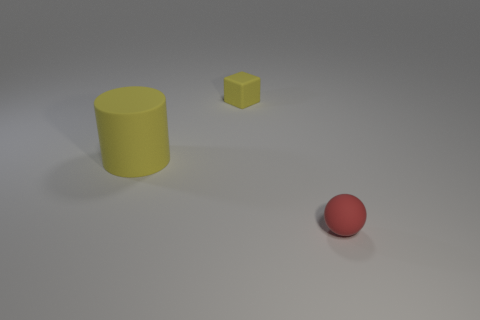How big is the rubber ball?
Provide a short and direct response. Small. Are there any tiny matte things on the left side of the yellow rubber thing that is on the left side of the yellow rubber object that is to the right of the big yellow cylinder?
Offer a very short reply. No. How many big things are either green blocks or yellow rubber blocks?
Provide a short and direct response. 0. Is there anything else that is the same color as the rubber block?
Give a very brief answer. Yes. There is a yellow object behind the yellow matte cylinder; does it have the same size as the small rubber ball?
Your answer should be very brief. Yes. What color is the tiny object that is in front of the object left of the yellow rubber thing that is behind the big matte cylinder?
Your answer should be compact. Red. What color is the small cube?
Offer a terse response. Yellow. Is the color of the cylinder the same as the cube?
Make the answer very short. Yes. There is a tiny object in front of the tiny object behind the tiny rubber ball; what color is it?
Provide a short and direct response. Red. What size is the cylinder that is the same material as the small yellow block?
Ensure brevity in your answer.  Large. 